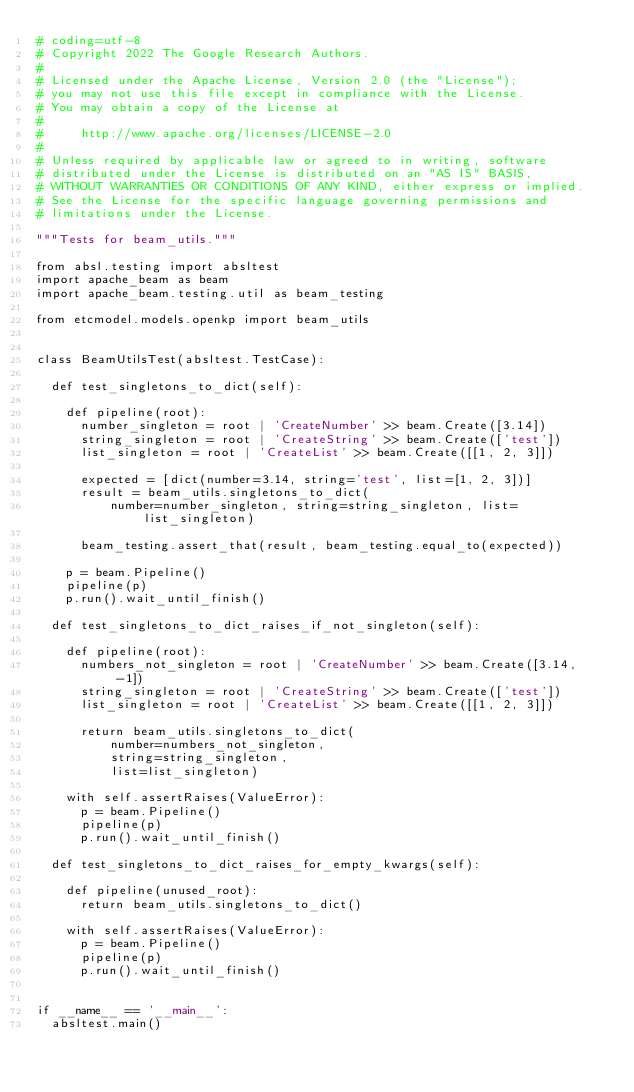Convert code to text. <code><loc_0><loc_0><loc_500><loc_500><_Python_># coding=utf-8
# Copyright 2022 The Google Research Authors.
#
# Licensed under the Apache License, Version 2.0 (the "License");
# you may not use this file except in compliance with the License.
# You may obtain a copy of the License at
#
#     http://www.apache.org/licenses/LICENSE-2.0
#
# Unless required by applicable law or agreed to in writing, software
# distributed under the License is distributed on an "AS IS" BASIS,
# WITHOUT WARRANTIES OR CONDITIONS OF ANY KIND, either express or implied.
# See the License for the specific language governing permissions and
# limitations under the License.

"""Tests for beam_utils."""

from absl.testing import absltest
import apache_beam as beam
import apache_beam.testing.util as beam_testing

from etcmodel.models.openkp import beam_utils


class BeamUtilsTest(absltest.TestCase):

  def test_singletons_to_dict(self):

    def pipeline(root):
      number_singleton = root | 'CreateNumber' >> beam.Create([3.14])
      string_singleton = root | 'CreateString' >> beam.Create(['test'])
      list_singleton = root | 'CreateList' >> beam.Create([[1, 2, 3]])

      expected = [dict(number=3.14, string='test', list=[1, 2, 3])]
      result = beam_utils.singletons_to_dict(
          number=number_singleton, string=string_singleton, list=list_singleton)

      beam_testing.assert_that(result, beam_testing.equal_to(expected))

    p = beam.Pipeline()
    pipeline(p)
    p.run().wait_until_finish()

  def test_singletons_to_dict_raises_if_not_singleton(self):

    def pipeline(root):
      numbers_not_singleton = root | 'CreateNumber' >> beam.Create([3.14, -1])
      string_singleton = root | 'CreateString' >> beam.Create(['test'])
      list_singleton = root | 'CreateList' >> beam.Create([[1, 2, 3]])

      return beam_utils.singletons_to_dict(
          number=numbers_not_singleton,
          string=string_singleton,
          list=list_singleton)

    with self.assertRaises(ValueError):
      p = beam.Pipeline()
      pipeline(p)
      p.run().wait_until_finish()

  def test_singletons_to_dict_raises_for_empty_kwargs(self):

    def pipeline(unused_root):
      return beam_utils.singletons_to_dict()

    with self.assertRaises(ValueError):
      p = beam.Pipeline()
      pipeline(p)
      p.run().wait_until_finish()


if __name__ == '__main__':
  absltest.main()
</code> 